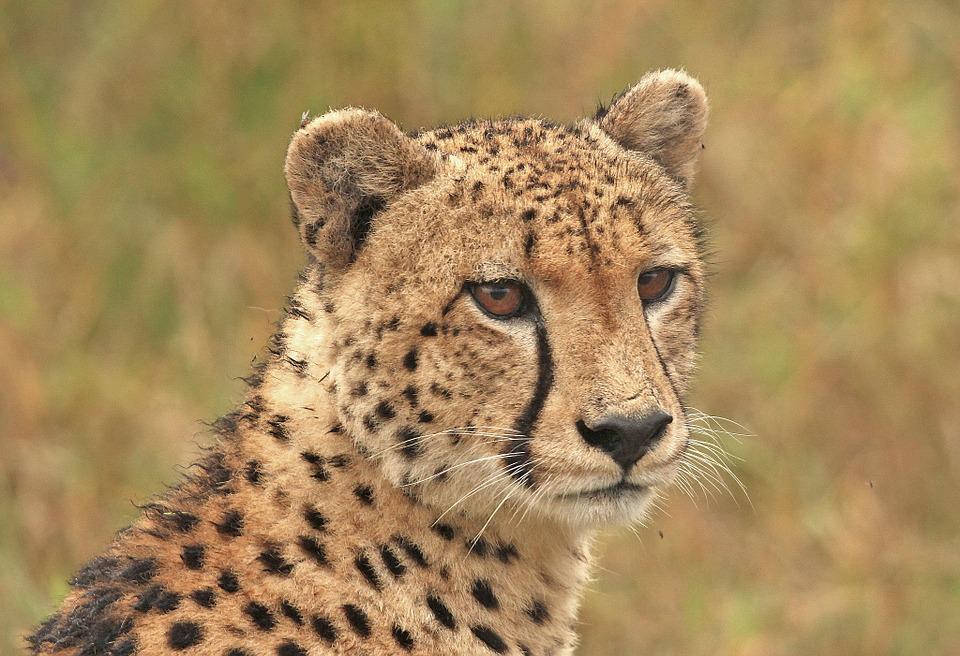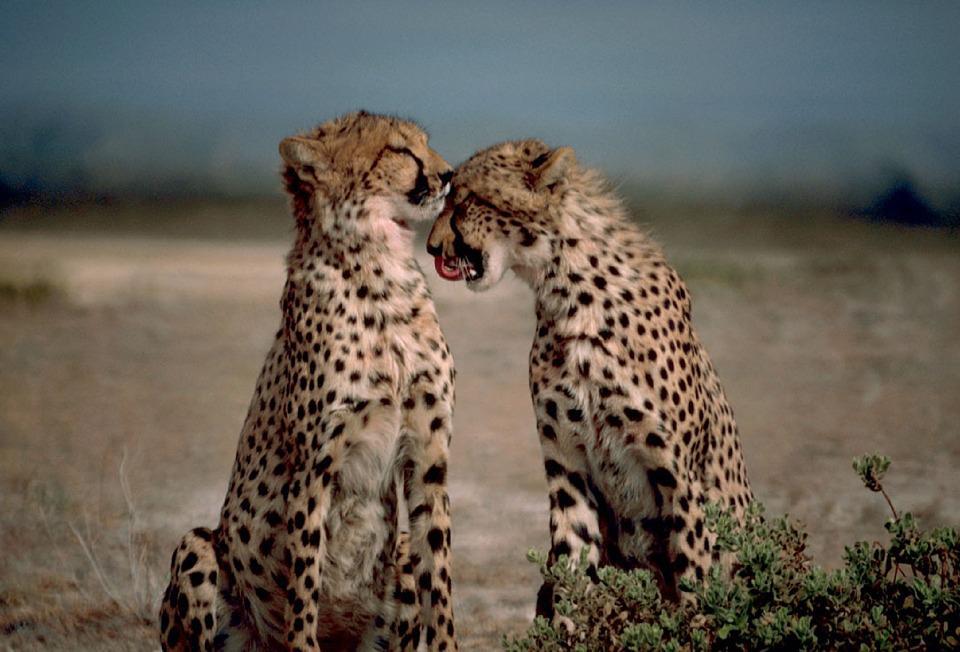The first image is the image on the left, the second image is the image on the right. Analyze the images presented: Is the assertion "There are two cats in the image on the right." valid? Answer yes or no. Yes. 